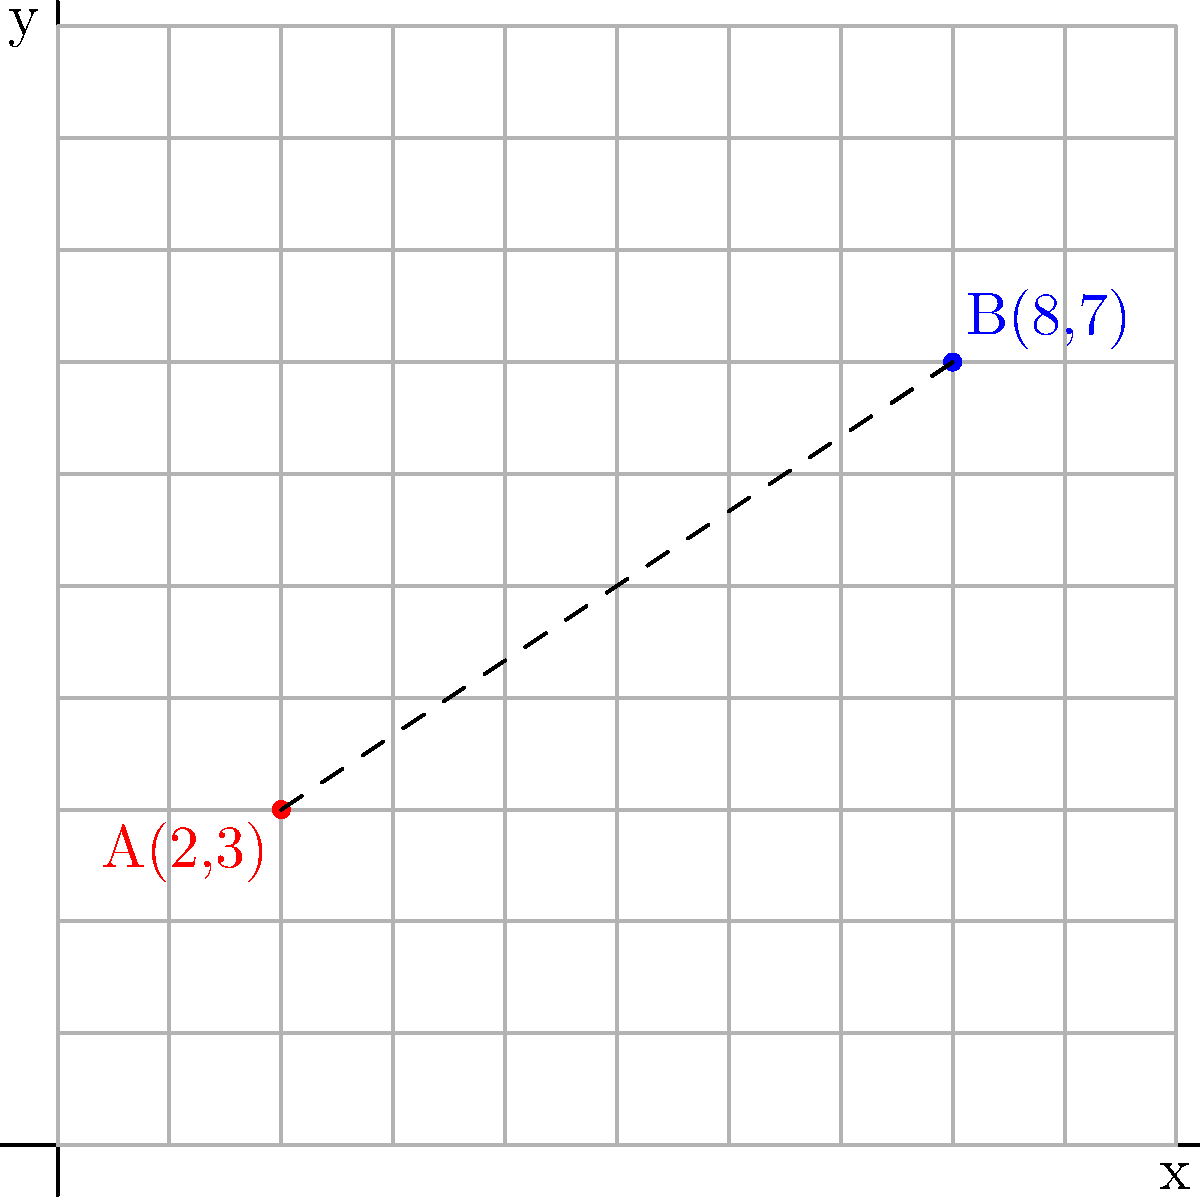On our freelancing platform's new geo-location feature, we're testing the distance calculation between freelancers. Given two freelancers, A at coordinates (2,3) and B at (8,7) on our grid system where each unit represents 10 km, what is the straight-line distance between them in kilometers? To find the straight-line distance between two points on a grid, we can use the distance formula, which is derived from the Pythagorean theorem:

$$ d = \sqrt{(x_2 - x_1)^2 + (y_2 - y_1)^2} $$

Where $(x_1, y_1)$ are the coordinates of point A and $(x_2, y_2)$ are the coordinates of point B.

Step 1: Identify the coordinates
- Point A: $(x_1, y_1) = (2, 3)$
- Point B: $(x_2, y_2) = (8, 7)$

Step 2: Plug the values into the distance formula
$$ d = \sqrt{(8 - 2)^2 + (7 - 3)^2} $$

Step 3: Simplify the expressions inside the parentheses
$$ d = \sqrt{6^2 + 4^2} $$

Step 4: Calculate the squares
$$ d = \sqrt{36 + 16} $$

Step 5: Add the values under the square root
$$ d = \sqrt{52} $$

Step 6: Simplify the square root
$$ d = 2\sqrt{13} $$

Step 7: Convert to kilometers
Since each unit represents 10 km, we multiply our result by 10:

$$ d = 20\sqrt{13} \text{ km} $$

This can be approximated to about 72.11 km.
Answer: $20\sqrt{13}$ km 